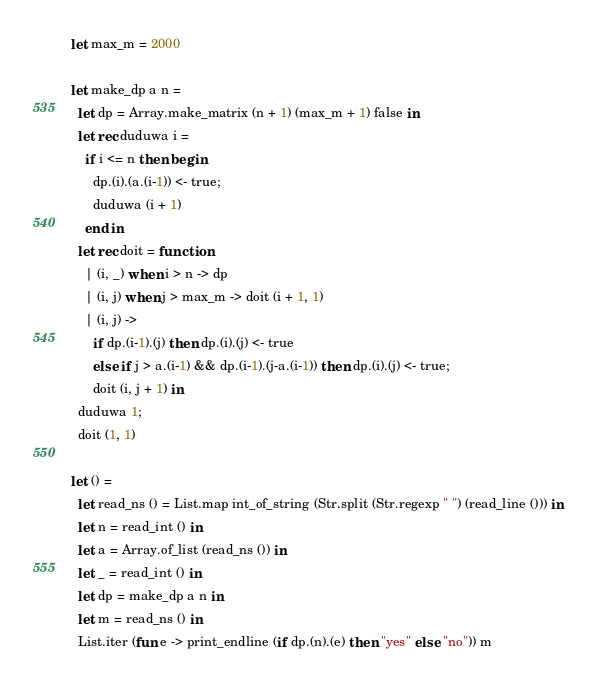Convert code to text. <code><loc_0><loc_0><loc_500><loc_500><_OCaml_>let max_m = 2000

let make_dp a n =
  let dp = Array.make_matrix (n + 1) (max_m + 1) false in
  let rec duduwa i =
    if i <= n then begin
      dp.(i).(a.(i-1)) <- true;
      duduwa (i + 1)
    end in
  let rec doit = function
    | (i, _) when i > n -> dp
    | (i, j) when j > max_m -> doit (i + 1, 1)
    | (i, j) ->
      if dp.(i-1).(j) then dp.(i).(j) <- true
      else if j > a.(i-1) && dp.(i-1).(j-a.(i-1)) then dp.(i).(j) <- true;
      doit (i, j + 1) in
  duduwa 1;
  doit (1, 1)

let () =
  let read_ns () = List.map int_of_string (Str.split (Str.regexp " ") (read_line ())) in
  let n = read_int () in
  let a = Array.of_list (read_ns ()) in
  let _ = read_int () in
  let dp = make_dp a n in
  let m = read_ns () in
  List.iter (fun e -> print_endline (if dp.(n).(e) then "yes" else "no")) m</code> 